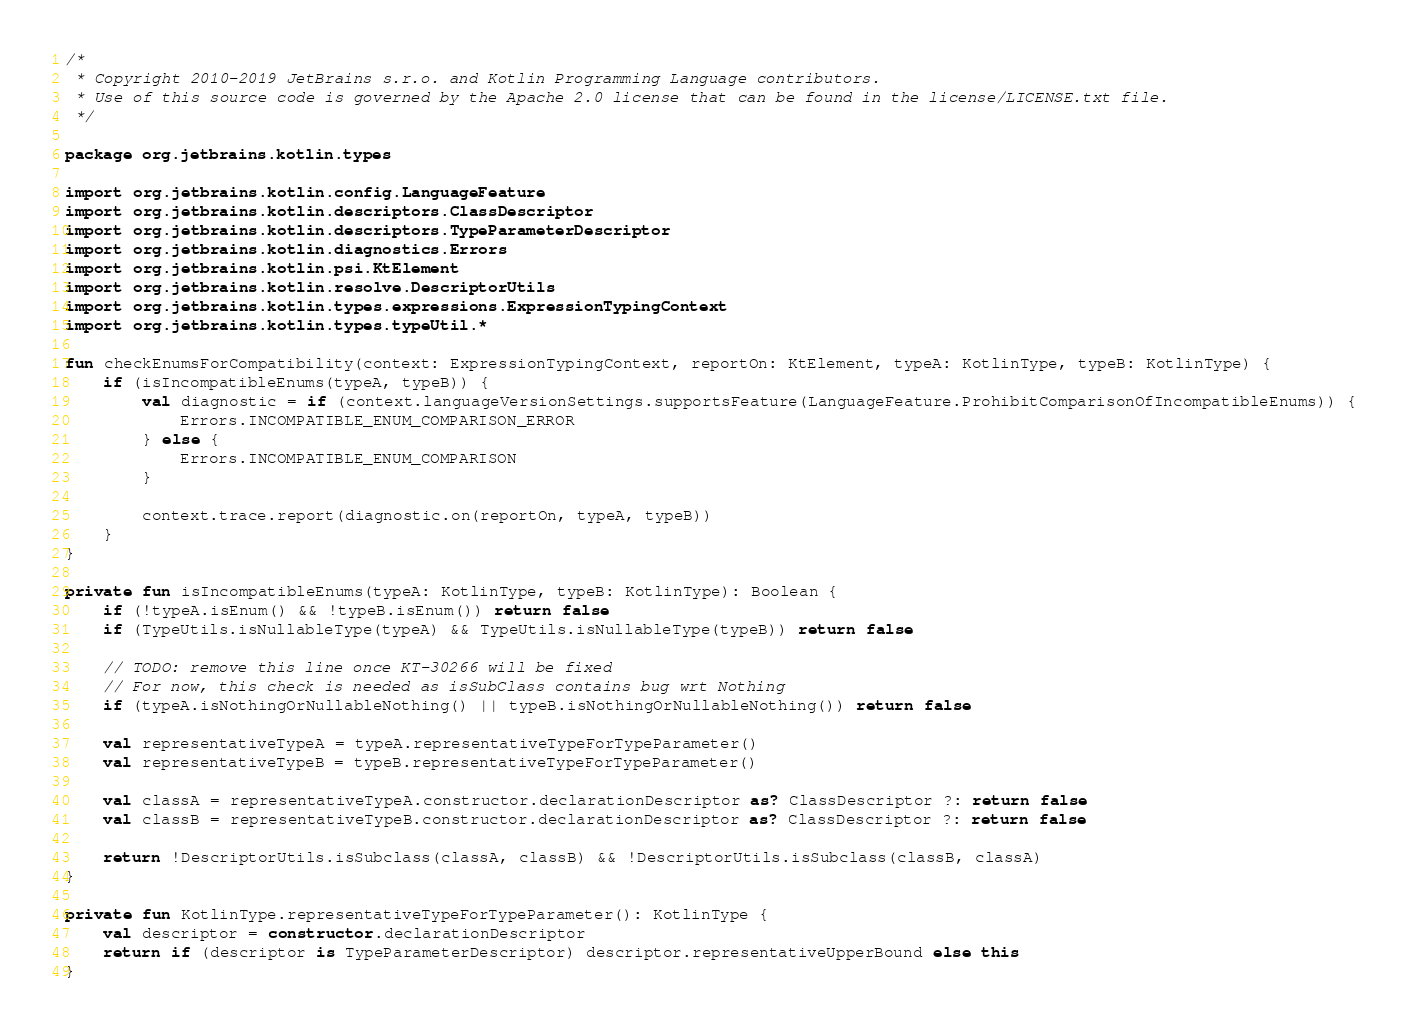<code> <loc_0><loc_0><loc_500><loc_500><_Kotlin_>/*
 * Copyright 2010-2019 JetBrains s.r.o. and Kotlin Programming Language contributors.
 * Use of this source code is governed by the Apache 2.0 license that can be found in the license/LICENSE.txt file.
 */

package org.jetbrains.kotlin.types

import org.jetbrains.kotlin.config.LanguageFeature
import org.jetbrains.kotlin.descriptors.ClassDescriptor
import org.jetbrains.kotlin.descriptors.TypeParameterDescriptor
import org.jetbrains.kotlin.diagnostics.Errors
import org.jetbrains.kotlin.psi.KtElement
import org.jetbrains.kotlin.resolve.DescriptorUtils
import org.jetbrains.kotlin.types.expressions.ExpressionTypingContext
import org.jetbrains.kotlin.types.typeUtil.*

fun checkEnumsForCompatibility(context: ExpressionTypingContext, reportOn: KtElement, typeA: KotlinType, typeB: KotlinType) {
    if (isIncompatibleEnums(typeA, typeB)) {
        val diagnostic = if (context.languageVersionSettings.supportsFeature(LanguageFeature.ProhibitComparisonOfIncompatibleEnums)) {
            Errors.INCOMPATIBLE_ENUM_COMPARISON_ERROR
        } else {
            Errors.INCOMPATIBLE_ENUM_COMPARISON
        }

        context.trace.report(diagnostic.on(reportOn, typeA, typeB))
    }
}

private fun isIncompatibleEnums(typeA: KotlinType, typeB: KotlinType): Boolean {
    if (!typeA.isEnum() && !typeB.isEnum()) return false
    if (TypeUtils.isNullableType(typeA) && TypeUtils.isNullableType(typeB)) return false

    // TODO: remove this line once KT-30266 will be fixed
    // For now, this check is needed as isSubClass contains bug wrt Nothing
    if (typeA.isNothingOrNullableNothing() || typeB.isNothingOrNullableNothing()) return false

    val representativeTypeA = typeA.representativeTypeForTypeParameter()
    val representativeTypeB = typeB.representativeTypeForTypeParameter()

    val classA = representativeTypeA.constructor.declarationDescriptor as? ClassDescriptor ?: return false
    val classB = representativeTypeB.constructor.declarationDescriptor as? ClassDescriptor ?: return false

    return !DescriptorUtils.isSubclass(classA, classB) && !DescriptorUtils.isSubclass(classB, classA)
}

private fun KotlinType.representativeTypeForTypeParameter(): KotlinType {
    val descriptor = constructor.declarationDescriptor
    return if (descriptor is TypeParameterDescriptor) descriptor.representativeUpperBound else this
}
</code> 